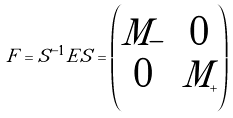<formula> <loc_0><loc_0><loc_500><loc_500>F = \tilde { S } ^ { - 1 } E \tilde { S } = \begin{pmatrix} M _ { - } & 0 \\ 0 & M _ { + } \end{pmatrix}</formula> 